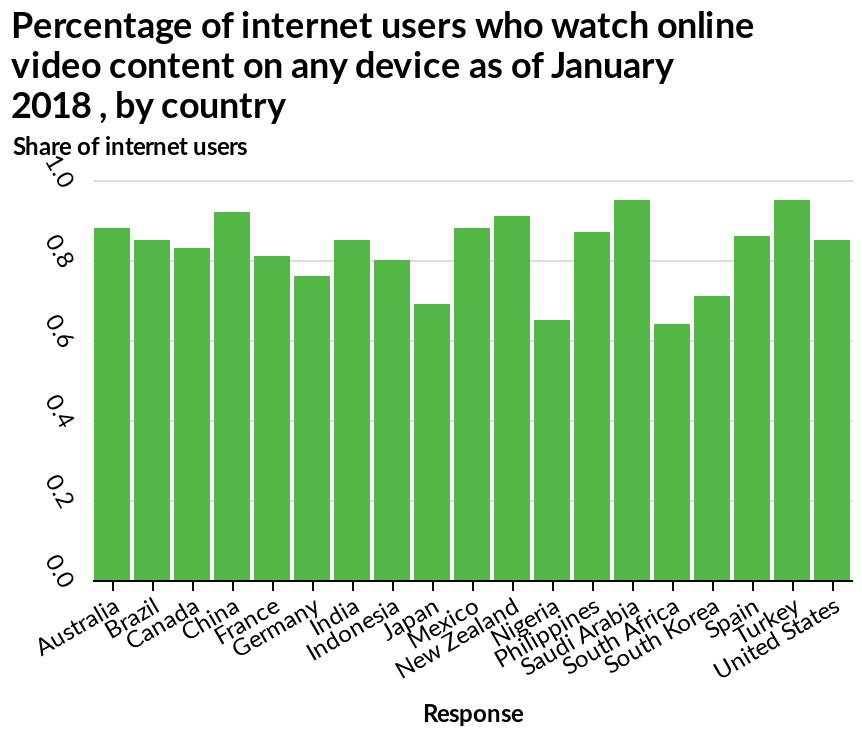<image>
What is the range of internet users who watch video content online across the countries mentioned?  It ranges from 0.6% in South Africa to over 0.9% in China, Saudi Arabia, and Turkey. What percentage of internet users in South Africa watch video content online?  0.6% What is the approximate percentage of internet users in most measured countries who watch video content online? Between 0.8% and 0.9%. 